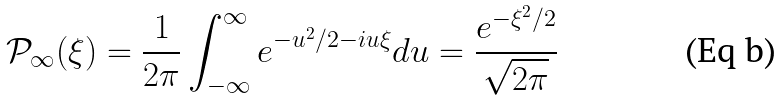Convert formula to latex. <formula><loc_0><loc_0><loc_500><loc_500>\mathcal { P } _ { \infty } ( \xi ) = \frac { 1 } { 2 \pi } \int _ { - \infty } ^ { \infty } e ^ { - u ^ { 2 } / 2 - i u \xi } d u = \frac { e ^ { - \xi ^ { 2 } / 2 } } { \sqrt { 2 \pi } }</formula> 